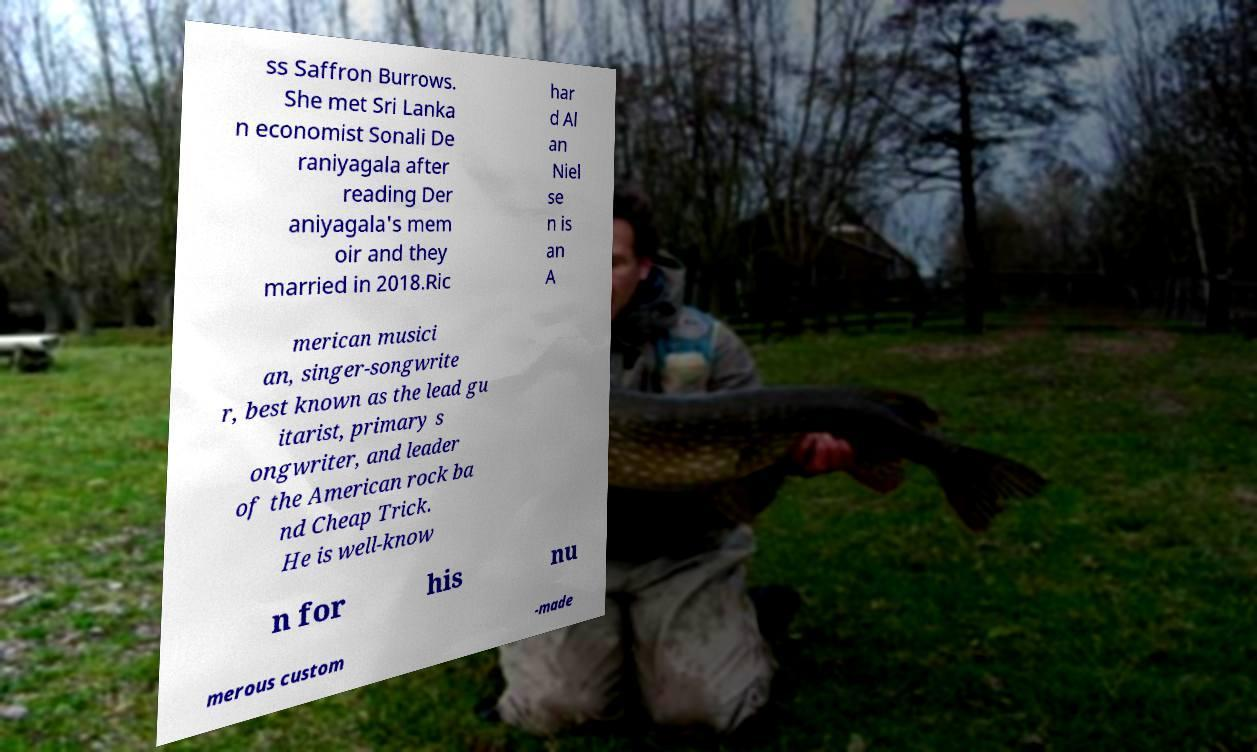What messages or text are displayed in this image? I need them in a readable, typed format. ss Saffron Burrows. She met Sri Lanka n economist Sonali De raniyagala after reading Der aniyagala's mem oir and they married in 2018.Ric har d Al an Niel se n is an A merican musici an, singer-songwrite r, best known as the lead gu itarist, primary s ongwriter, and leader of the American rock ba nd Cheap Trick. He is well-know n for his nu merous custom -made 